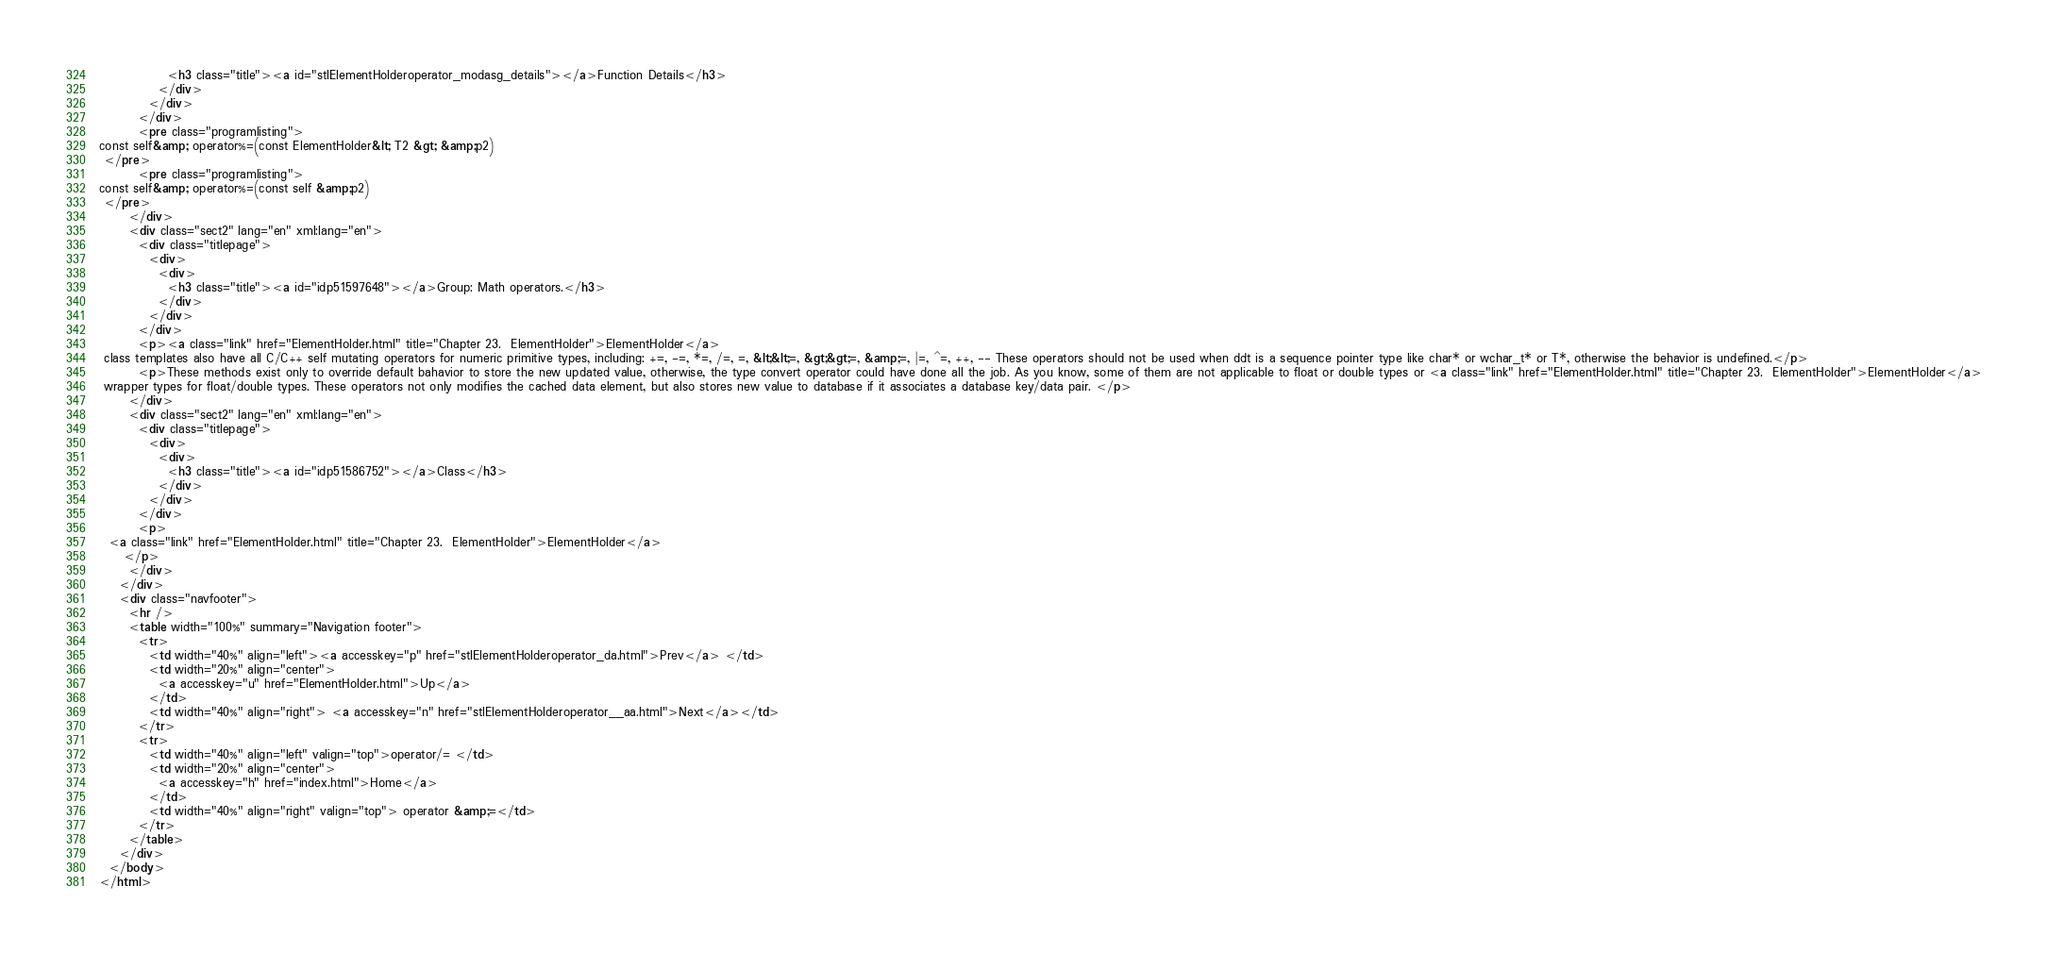<code> <loc_0><loc_0><loc_500><loc_500><_HTML_>              <h3 class="title"><a id="stlElementHolderoperator_modasg_details"></a>Function Details</h3>
            </div>
          </div>
        </div>
        <pre class="programlisting">
const self&amp; operator%=(const ElementHolder&lt; T2 &gt; &amp;p2)
 </pre>
        <pre class="programlisting">
const self&amp; operator%=(const self &amp;p2)
 </pre>
      </div>
      <div class="sect2" lang="en" xml:lang="en">
        <div class="titlepage">
          <div>
            <div>
              <h3 class="title"><a id="idp51597648"></a>Group: Math operators.</h3>
            </div>
          </div>
        </div>
        <p><a class="link" href="ElementHolder.html" title="Chapter 23.  ElementHolder">ElementHolder</a>
 class templates also have all C/C++ self mutating operators for numeric primitive types, including: +=, -=, *=, /=, =, &lt;&lt;=, &gt;&gt;=, &amp;=, |=, ^=, ++, -- These operators should not be used when ddt is a sequence pointer type like char* or wchar_t* or T*, otherwise the behavior is undefined.</p>
        <p>These methods exist only to override default bahavior to store the new updated value, otherwise, the type convert operator could have done all the job. As you know, some of them are not applicable to float or double types or <a class="link" href="ElementHolder.html" title="Chapter 23.  ElementHolder">ElementHolder</a>
 wrapper types for float/double types. These operators not only modifies the cached data element, but also stores new value to database if it associates a database key/data pair. </p>
      </div>
      <div class="sect2" lang="en" xml:lang="en">
        <div class="titlepage">
          <div>
            <div>
              <h3 class="title"><a id="idp51586752"></a>Class</h3>
            </div>
          </div>
        </div>
        <p>
  <a class="link" href="ElementHolder.html" title="Chapter 23.  ElementHolder">ElementHolder</a>
     </p>
      </div>
    </div>
    <div class="navfooter">
      <hr />
      <table width="100%" summary="Navigation footer">
        <tr>
          <td width="40%" align="left"><a accesskey="p" href="stlElementHolderoperator_da.html">Prev</a> </td>
          <td width="20%" align="center">
            <a accesskey="u" href="ElementHolder.html">Up</a>
          </td>
          <td width="40%" align="right"> <a accesskey="n" href="stlElementHolderoperator__aa.html">Next</a></td>
        </tr>
        <tr>
          <td width="40%" align="left" valign="top">operator/= </td>
          <td width="20%" align="center">
            <a accesskey="h" href="index.html">Home</a>
          </td>
          <td width="40%" align="right" valign="top"> operator &amp;=</td>
        </tr>
      </table>
    </div>
  </body>
</html>
</code> 